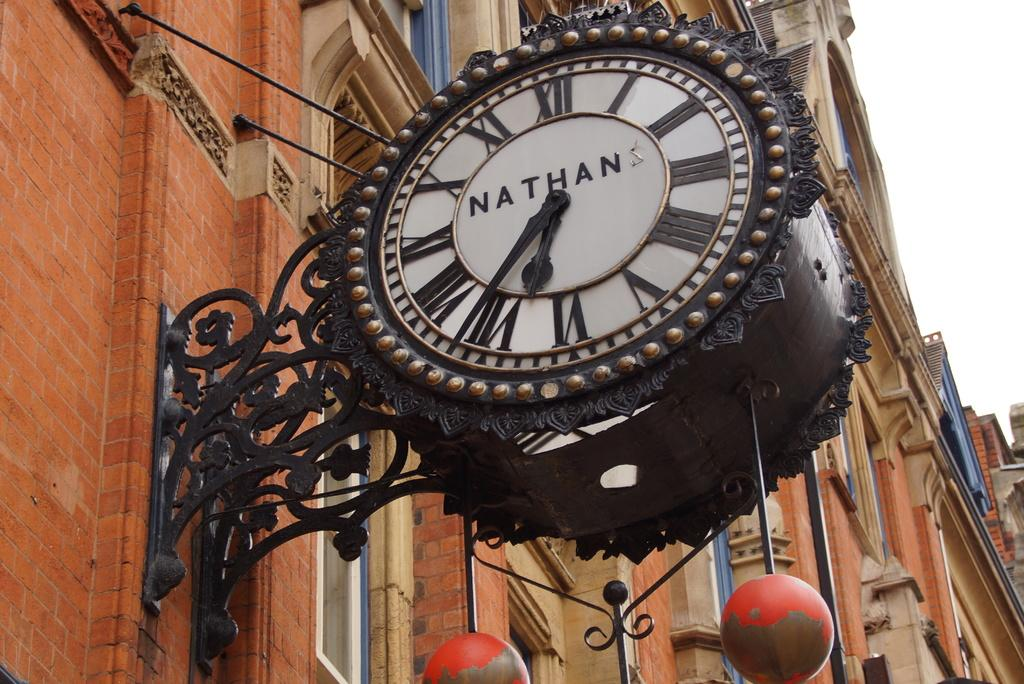<image>
Provide a brief description of the given image. A clock which has Roman numerals and the word Nathan on its face. 